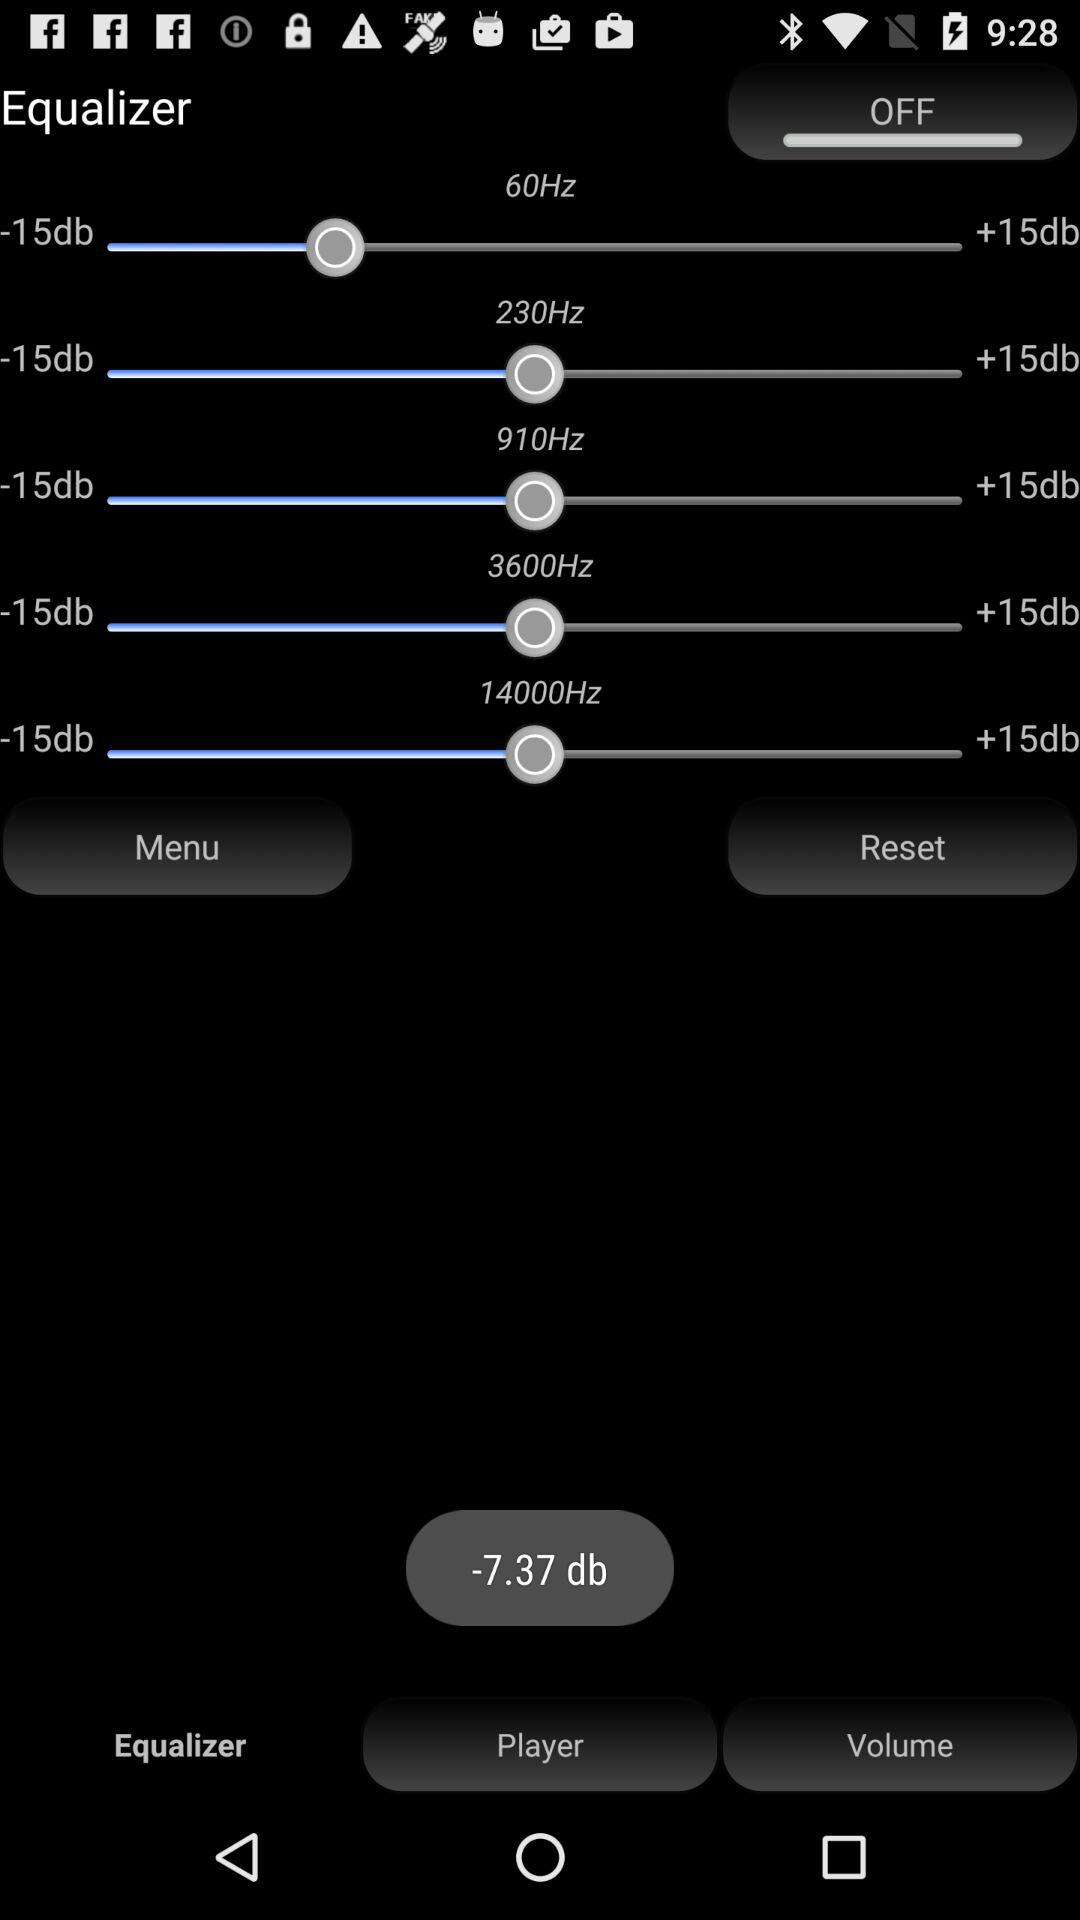How many frequency bands are there in the equalizer?
Answer the question using a single word or phrase. 5 